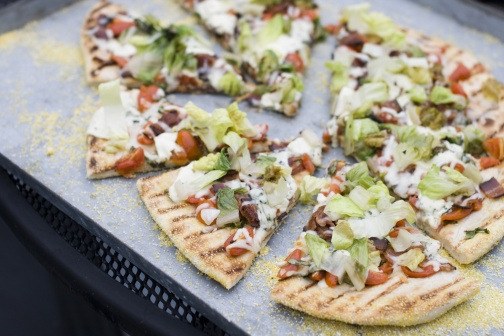If you could magically add another topping to this pizza, what would it be and why? If I could add another topping to this already delightful pizza, I would choose sun-dried tomatoes. Their rich, intense flavor would add a wonderful, tangy sweetness that complements the fresh lettuce and tomatoes perfectly. Sun-dried tomatoes also bring a chewy texture, adding another layer of complexity to each bite. Imagine this pizza is the star of a food festival. What kind of festival would it be and what other foods and activities could be found there? This pizza could be the main attraction at a 'Farm-to-Fork Food Festival,' a celebration that highlights fresh, locally-sourced ingredients. Alongside this pizza, you'd find an array of dishes like garden-fresh salads, artisan bread with herbed butter, and grilled vegetables all harvested from nearby farms. The festival would feature cooking demonstrations by local chefs, workshops on sustainable farming practices, and live music creating a festive atmosphere. Attendees could walk through stalls filled with local produce, handmade crafts, and sharegpt4v/sample an abundance of farm-fresh delicacies, making it a true feast for all the senses! The image looks so calm and inviting, can you describe a cozy night in with this pizza? On a chilly winter evening, the house is filled with the warmth and tantalizing aroma of a freshly baked pizza. The pizza, with its vibrant toppings of green lettuce, juicy tomatoes, and golden-brown melted cheese, is the star of the night. It rests on a sleek black tray, ready to be served. The family gathers around the fireplace, its glow casting a cozy light across the room. Woolen blankets and soft cushions are sprawled across the floor, inviting everyone to sink in and relax. Laughter and stories fill the air as slices of the pizza are shared, each bite bursting with fresh flavors and warmth. The simple yet delightful meal fosters a sense of comfort and togetherness, making the evening a perfect, cozy night in. 